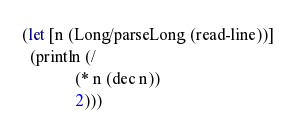Convert code to text. <code><loc_0><loc_0><loc_500><loc_500><_Clojure_>(let [n (Long/parseLong (read-line))]
  (println (/
             (* n (dec n))
             2)))
</code> 